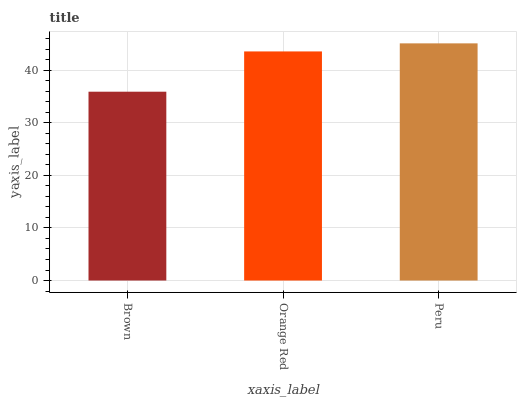Is Brown the minimum?
Answer yes or no. Yes. Is Peru the maximum?
Answer yes or no. Yes. Is Orange Red the minimum?
Answer yes or no. No. Is Orange Red the maximum?
Answer yes or no. No. Is Orange Red greater than Brown?
Answer yes or no. Yes. Is Brown less than Orange Red?
Answer yes or no. Yes. Is Brown greater than Orange Red?
Answer yes or no. No. Is Orange Red less than Brown?
Answer yes or no. No. Is Orange Red the high median?
Answer yes or no. Yes. Is Orange Red the low median?
Answer yes or no. Yes. Is Brown the high median?
Answer yes or no. No. Is Peru the low median?
Answer yes or no. No. 